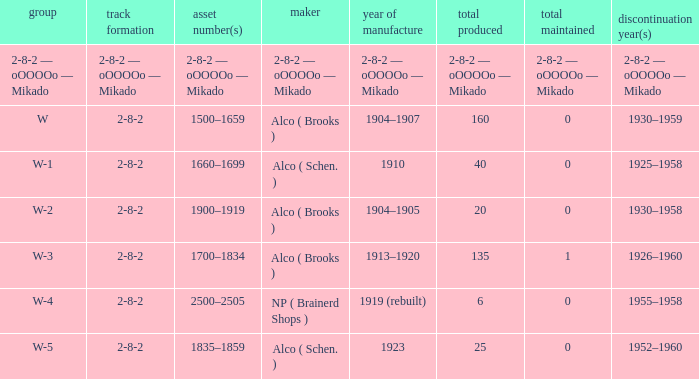What is the quantity preserved to the locomotive with a quantity made of 6? 0.0. Could you parse the entire table as a dict? {'header': ['group', 'track formation', 'asset number(s)', 'maker', 'year of manufacture', 'total produced', 'total maintained', 'discontinuation year(s)'], 'rows': [['2-8-2 — oOOOOo — Mikado', '2-8-2 — oOOOOo — Mikado', '2-8-2 — oOOOOo — Mikado', '2-8-2 — oOOOOo — Mikado', '2-8-2 — oOOOOo — Mikado', '2-8-2 — oOOOOo — Mikado', '2-8-2 — oOOOOo — Mikado', '2-8-2 — oOOOOo — Mikado'], ['W', '2-8-2', '1500–1659', 'Alco ( Brooks )', '1904–1907', '160', '0', '1930–1959'], ['W-1', '2-8-2', '1660–1699', 'Alco ( Schen. )', '1910', '40', '0', '1925–1958'], ['W-2', '2-8-2', '1900–1919', 'Alco ( Brooks )', '1904–1905', '20', '0', '1930–1958'], ['W-3', '2-8-2', '1700–1834', 'Alco ( Brooks )', '1913–1920', '135', '1', '1926–1960'], ['W-4', '2-8-2', '2500–2505', 'NP ( Brainerd Shops )', '1919 (rebuilt)', '6', '0', '1955–1958'], ['W-5', '2-8-2', '1835–1859', 'Alco ( Schen. )', '1923', '25', '0', '1952–1960']]} 